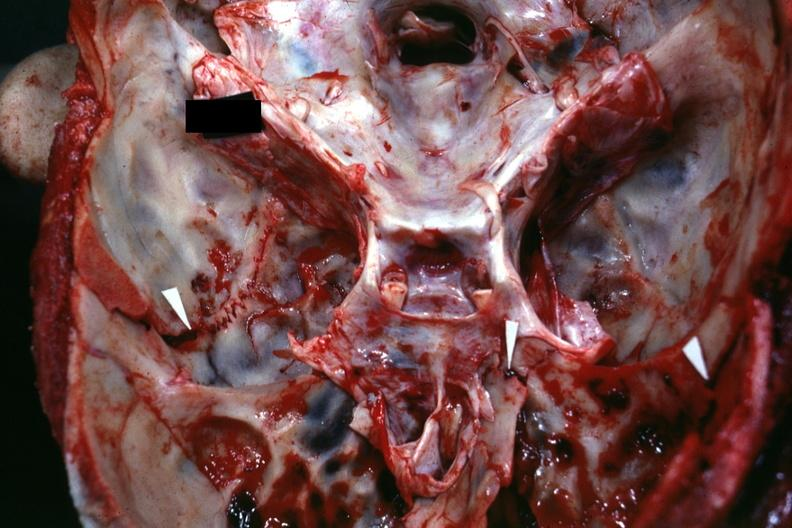how is close-up view of base of skull with shown shown fractures?
Answer the question using a single word or phrase. Several 